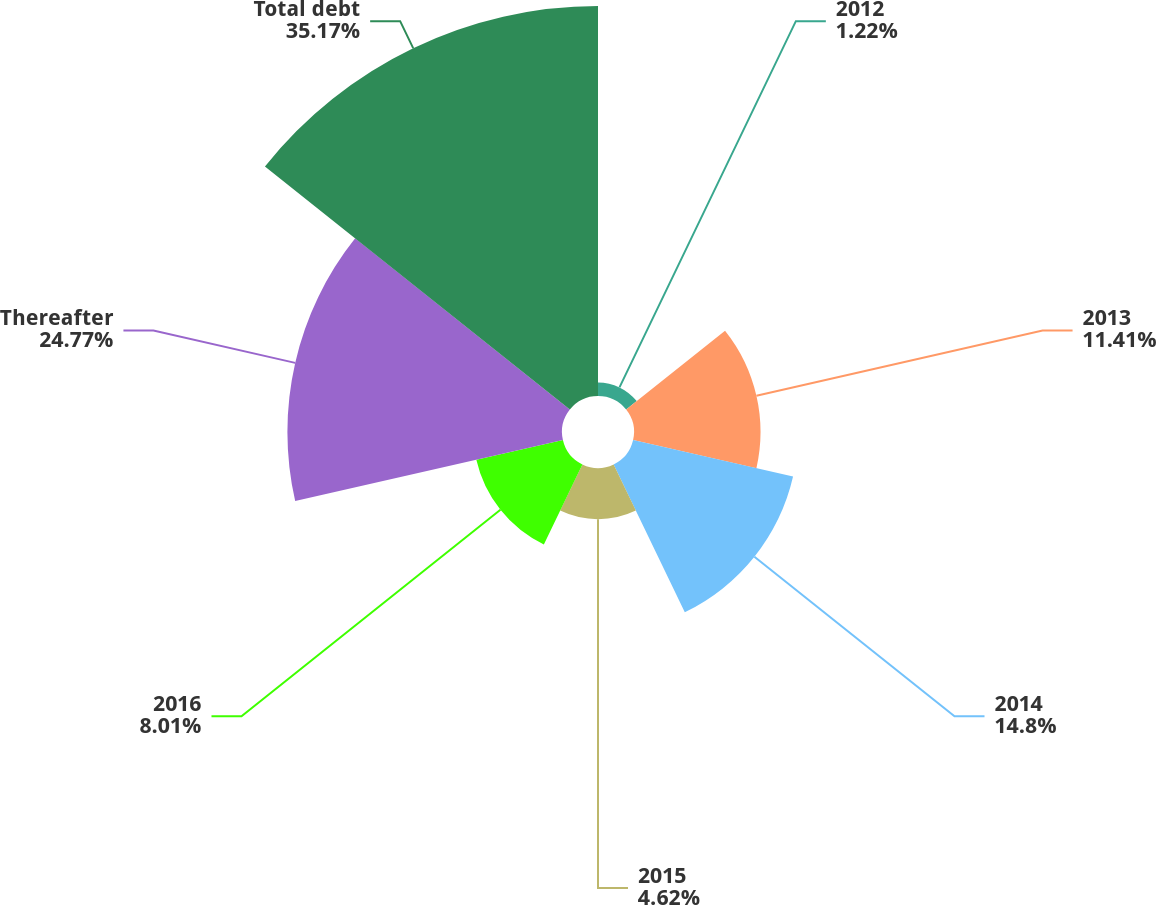<chart> <loc_0><loc_0><loc_500><loc_500><pie_chart><fcel>2012<fcel>2013<fcel>2014<fcel>2015<fcel>2016<fcel>Thereafter<fcel>Total debt<nl><fcel>1.22%<fcel>11.41%<fcel>14.8%<fcel>4.62%<fcel>8.01%<fcel>24.77%<fcel>35.18%<nl></chart> 